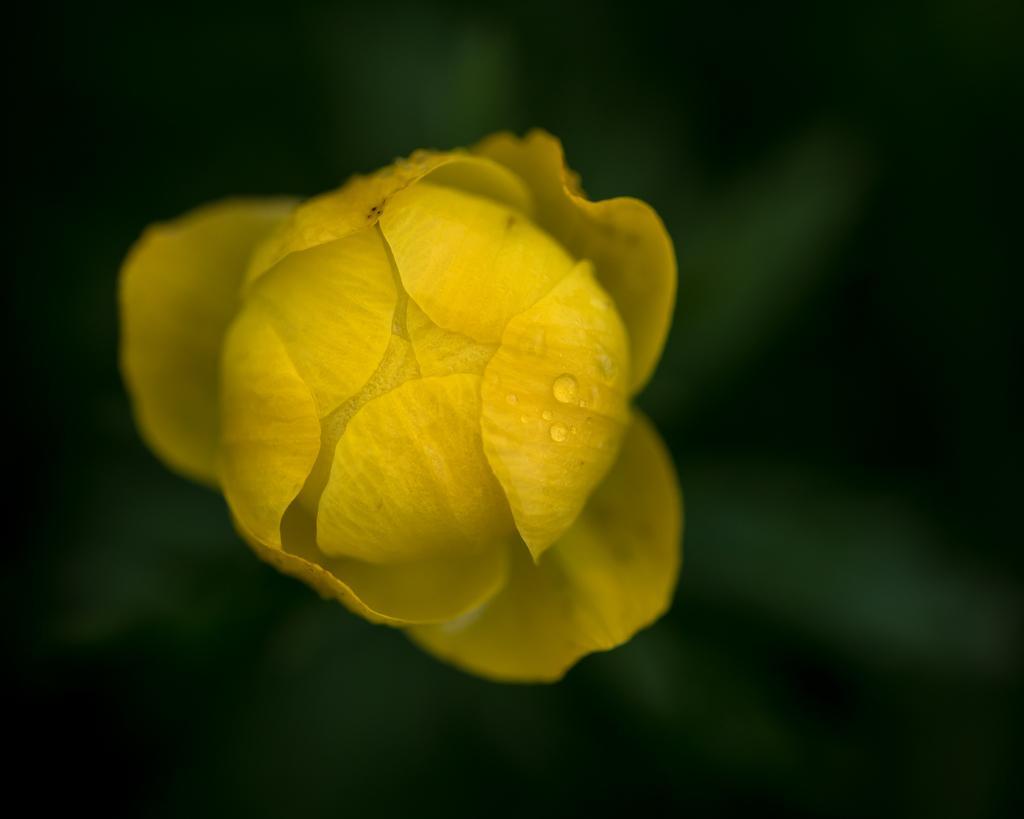Describe this image in one or two sentences. There are water drops on a yellow color flower. And the background is dark in color. 